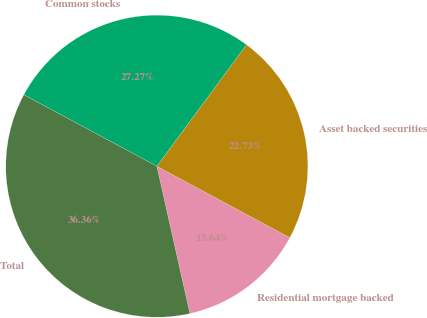<chart> <loc_0><loc_0><loc_500><loc_500><pie_chart><fcel>Residential mortgage backed<fcel>Asset backed securities<fcel>Common stocks<fcel>Total<nl><fcel>13.64%<fcel>22.73%<fcel>27.27%<fcel>36.36%<nl></chart> 